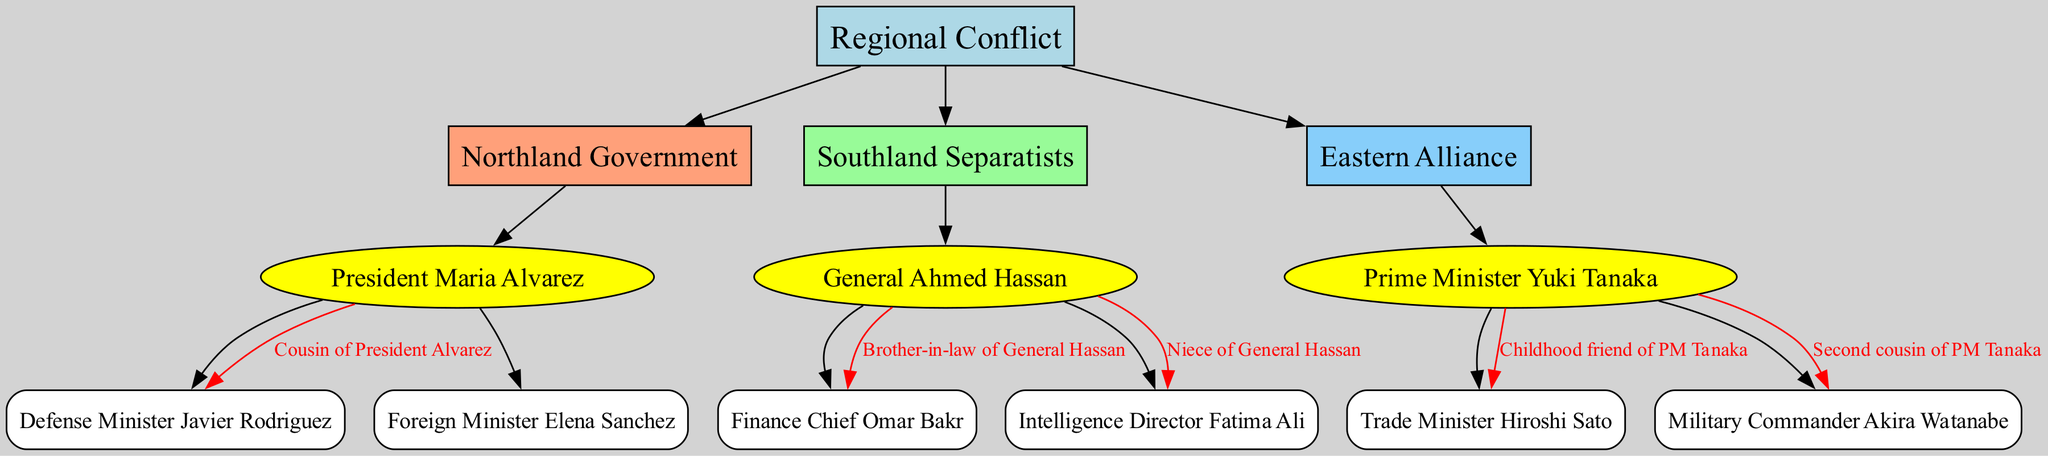What is the name of the leader of the Northland Government? The diagram provides a direct connection between the Northland Government node and its leader node. The leader listed for the Northland Government is President Maria Alvarez.
Answer: President Maria Alvarez Who is the Finance Chief of the Southland Separatists? The Finance Chief is directly connected to the Southland Separatists node and is identified as Omar Bakr.
Answer: Omar Bakr How many key members does the Eastern Alliance have? To find the number of key members, we count the number of connections from the leader node of the Eastern Alliance to its key member nodes. There are two key members: Trade Minister Hiroshi Sato and Military Commander Akira Watanabe.
Answer: 2 What is the relationship between General Ahmed Hassan and Fatima Ali? The diagram specifies the relationship directly, labeling Fatima Ali as the niece of General Ahmed Hassan.
Answer: Niece Who is a childhood friend of Prime Minister Yuki Tanaka? By analyzing the connections from the Eastern Alliance leader node, we see that Trade Minister Hiroshi Sato is labeled as a childhood friend of PM Tanaka.
Answer: Trade Minister Hiroshi Sato How is Defense Minister Javier Rodriguez related to President Alvarez? The relationship is explicitly indicated in the diagram, where it states that Javier Rodriguez is the cousin of President Alvarez.
Answer: Cousin What is the color of the node for Southland Separatists? The color of the nodes for the parties is specified in a sequence, and the Southland Separatists node is colored with the second color in the specified scheme, which is pale green (#98FB98).
Answer: Pale green Which party has a military commander as a key member? Looking through the diagram, we see the Eastern Alliance includes a key member identified as Military Commander Akira Watanabe.
Answer: Eastern Alliance Who is the leader of the Southland Separatists? The diagram indicates the leader of the Southland Separatists with a direct connection, which identifies General Ahmed Hassan as the leader.
Answer: General Ahmed Hassan 